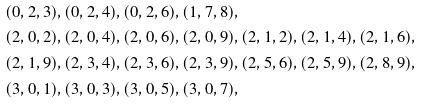<formula> <loc_0><loc_0><loc_500><loc_500>& ( 0 , 2 , 3 ) , ( 0 , 2 , 4 ) , ( 0 , 2 , 6 ) , ( 1 , 7 , 8 ) , \\ & ( 2 , 0 , 2 ) , ( 2 , 0 , 4 ) , ( 2 , 0 , 6 ) , ( 2 , 0 , 9 ) , ( 2 , 1 , 2 ) , ( 2 , 1 , 4 ) , ( 2 , 1 , 6 ) , \\ & ( 2 , 1 , 9 ) , ( 2 , 3 , 4 ) , ( 2 , 3 , 6 ) , ( 2 , 3 , 9 ) , ( 2 , 5 , 6 ) , ( 2 , 5 , 9 ) , ( 2 , 8 , 9 ) , \\ & ( 3 , 0 , 1 ) , ( 3 , 0 , 3 ) , ( 3 , 0 , 5 ) , ( 3 , 0 , 7 ) ,</formula> 